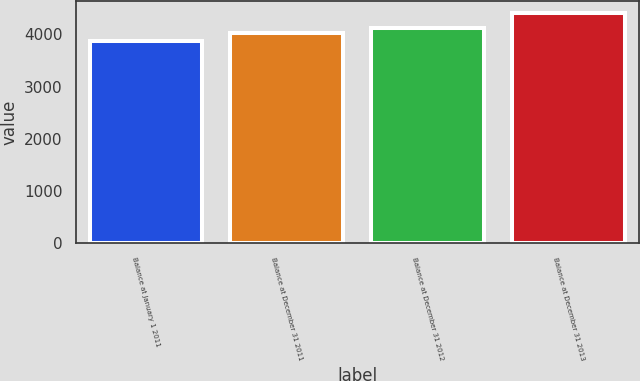<chart> <loc_0><loc_0><loc_500><loc_500><bar_chart><fcel>Balance at January 1 2011<fcel>Balance at December 31 2011<fcel>Balance at December 31 2012<fcel>Balance at December 31 2013<nl><fcel>3866<fcel>4033<fcel>4122<fcel>4415<nl></chart> 